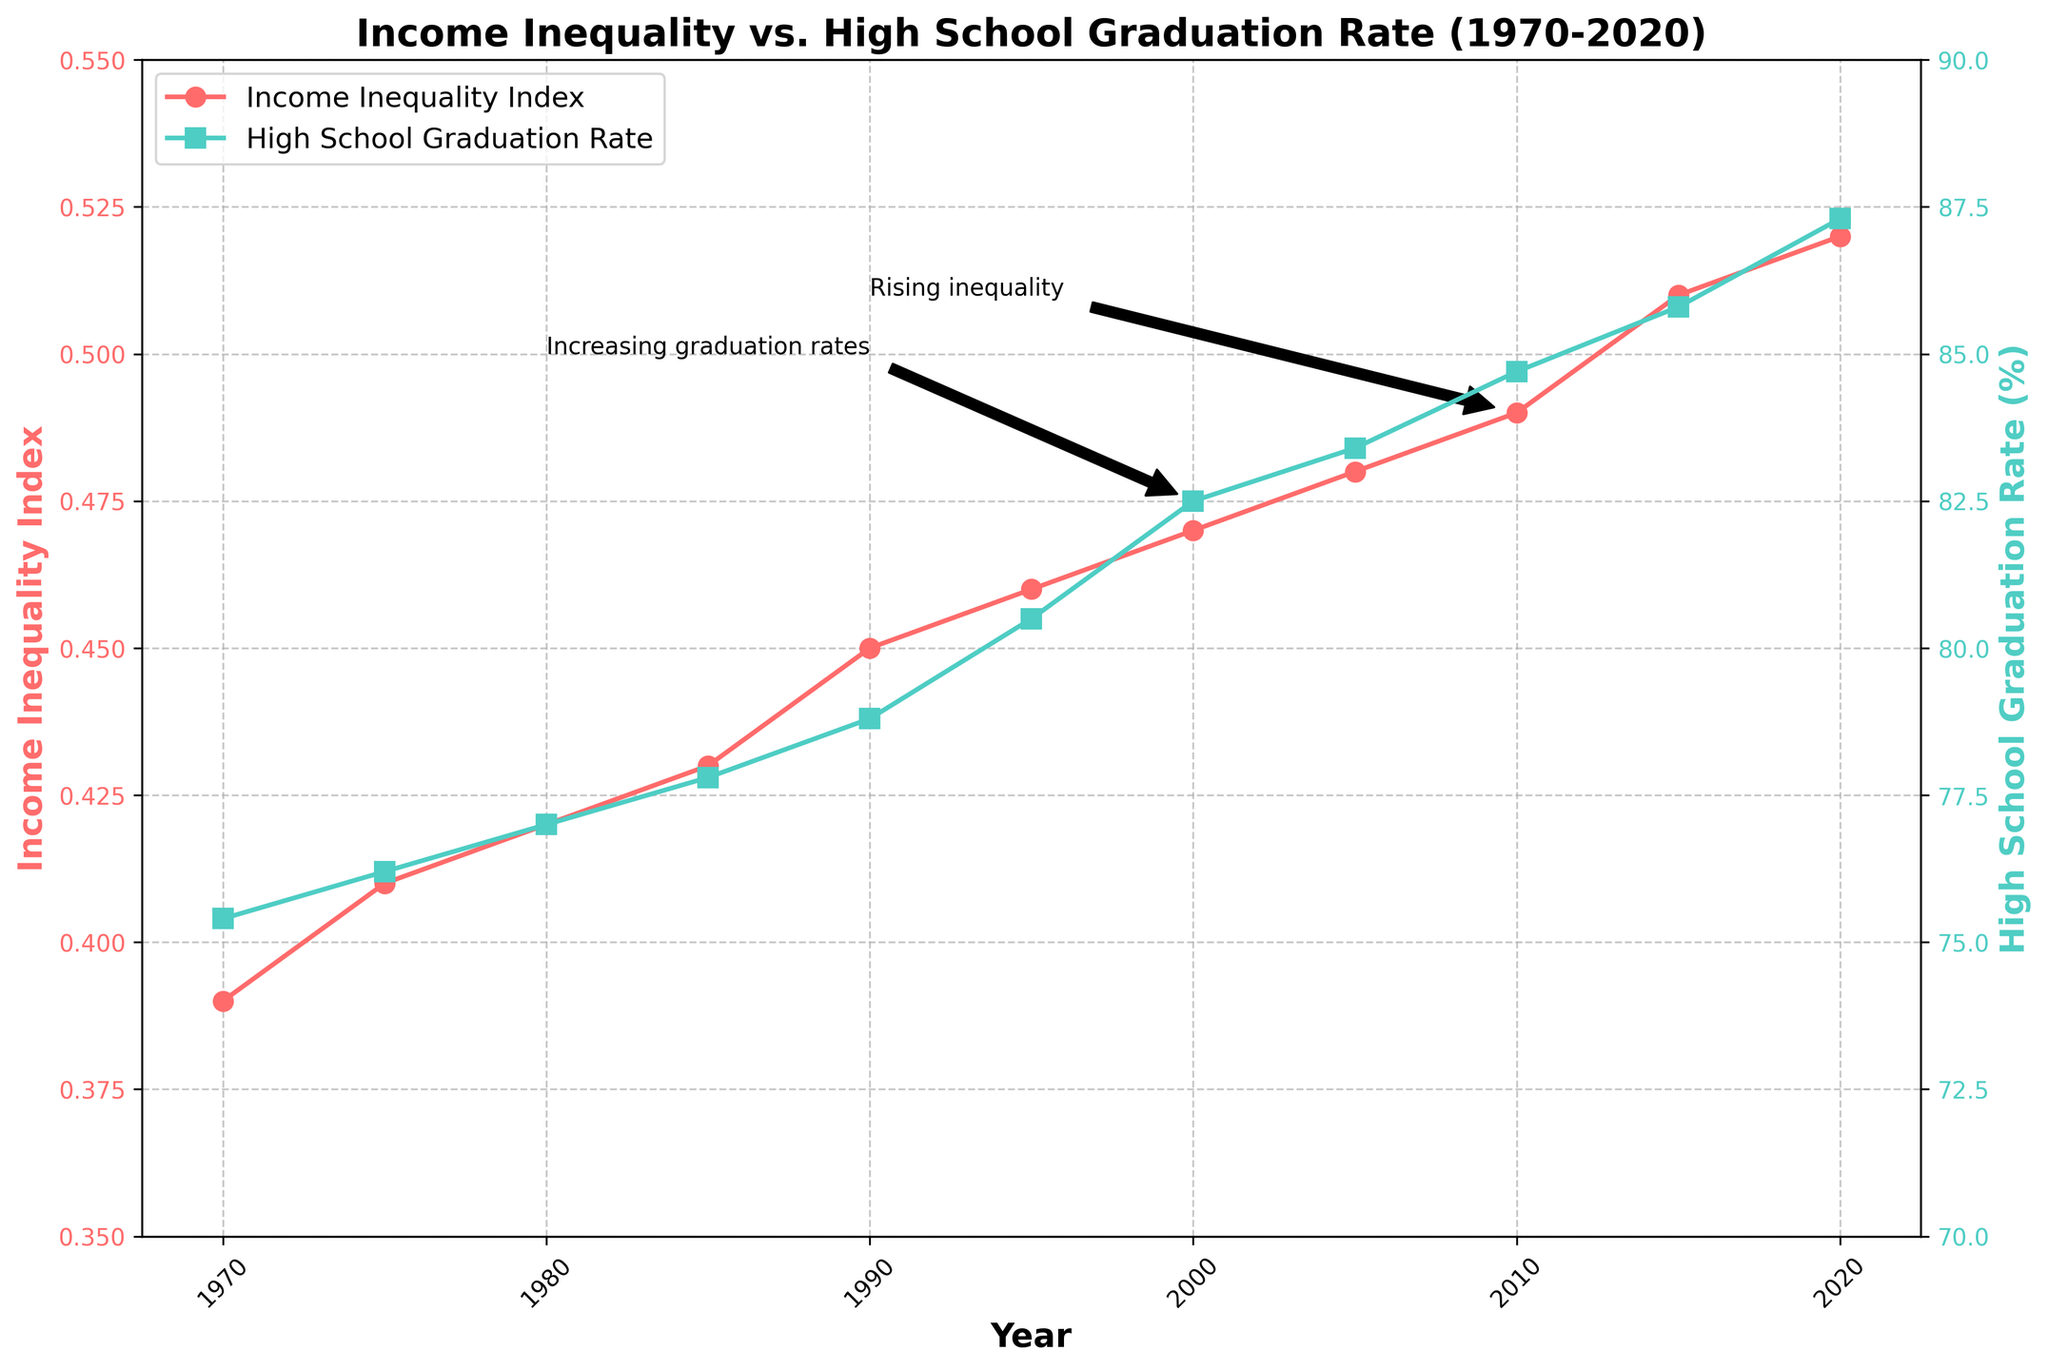What is the title of the figure? The title of the figure can be found at the top of the plot.
Answer: Income Inequality vs. High School Graduation Rate (1970-2020) How many data points are there in total? Count the number of data points plotted for either the Income Inequality Index or the High School Graduation Rate. Both series have the same number of data points.
Answer: 11 What are the colors for the Income Inequality Index and High School Graduation Rate lines? The colors can be determined by looking at the lines in the plot and matching them to the legends.
Answer: Red for Income Inequality Index, Teal for High School Graduation Rate Which metric has a higher value in the year 2020, the Income Inequality Index or the High School Graduation Rate? Cross-reference the values for the year 2020 for both metrics and compare them.
Answer: High School Graduation Rate What is the difference in the Income Inequality Index between the years 1970 and 2020? Subtract the value of the Income Inequality Index in 1970 from the value in 2020.
Answer: 0.13 Which year had the lowest High School Graduation Rate, and what was the rate? Look for the minimum point on the High School Graduation Rate line and cross-reference the year.
Answer: 1970, 75.4% How does the trend in the Income Inequality Index compare to the trend in the High School Graduation Rate from 1970 to 2020? Observe the overall direction of both trends over the 50 years. Both have upward trends, indicating an increase.
Answer: Both increased During which decade did the Income Inequality Index rise most sharply? Determine the decade where the slope of the Income Inequality Index line is steepest.
Answer: 1980s What can be inferred from the annotations on the plot? Cross-reference the text provided by the annotations with the respective data points on the plot.
Answer: Rising inequality and Increasing graduation rates What is the approximate average High School Graduation Rate over the plotted years? Sum up all the High School Graduation Rates from 1970 to 2020 and divide by the number of data points, which is 11. Calculation: \( (75.4 + 76.2 + 77 + 77.8 + 78.8 + 80.5 + 82.5 + 83.4 + 84.7 + 85.8 + 87.3) / 11 = 80.95 \)
Answer: 80.95 